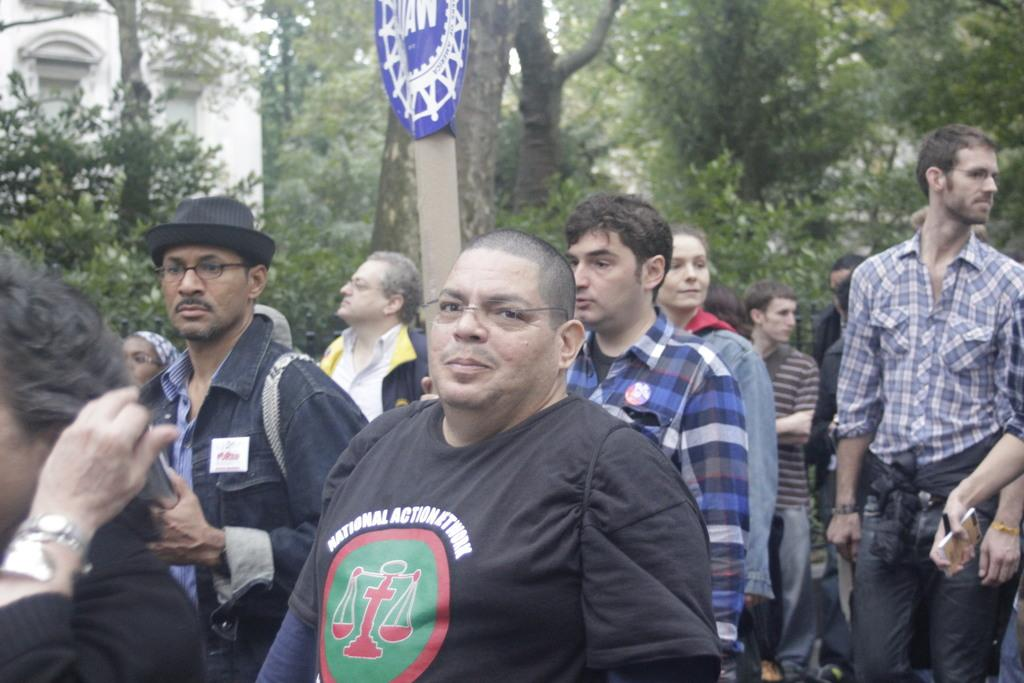<image>
Present a compact description of the photo's key features. a man walking among others with the word action on his shirt 